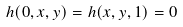<formula> <loc_0><loc_0><loc_500><loc_500>h ( 0 , x , y ) = h ( x , y , 1 ) = 0</formula> 